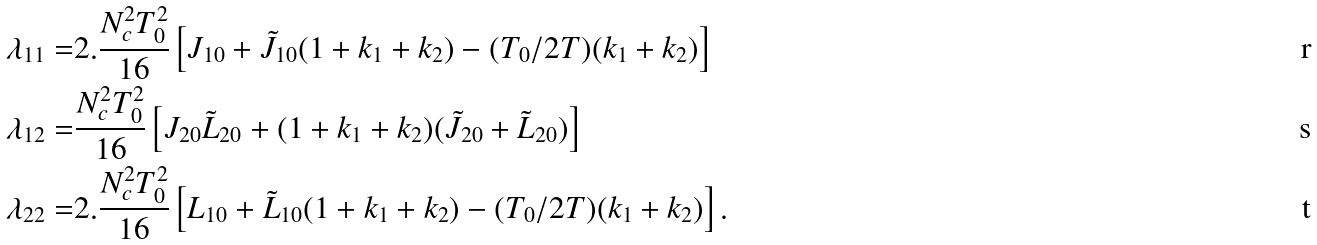Convert formula to latex. <formula><loc_0><loc_0><loc_500><loc_500>\lambda _ { 1 1 } = & 2 . \frac { N _ { c } ^ { 2 } T _ { 0 } ^ { 2 } } { 1 6 } \left [ J _ { 1 0 } + { \tilde { J } } _ { 1 0 } ( 1 + k _ { 1 } + k _ { 2 } ) - ( T _ { 0 } / 2 T ) ( k _ { 1 } + k _ { 2 } ) \right ] \\ \lambda _ { 1 2 } = & \frac { N _ { c } ^ { 2 } T _ { 0 } ^ { 2 } } { 1 6 } \left [ J _ { 2 0 } { \tilde { L } } _ { 2 0 } + ( 1 + k _ { 1 } + k _ { 2 } ) ( { \tilde { J } } _ { 2 0 } + { \tilde { L } } _ { 2 0 } ) \right ] \\ \lambda _ { 2 2 } = & 2 . \frac { N _ { c } ^ { 2 } T _ { 0 } ^ { 2 } } { 1 6 } \left [ L _ { 1 0 } + { \tilde { L } } _ { 1 0 } ( 1 + k _ { 1 } + k _ { 2 } ) - ( T _ { 0 } / 2 T ) ( k _ { 1 } + k _ { 2 } ) \right ] .</formula> 